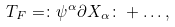Convert formula to latex. <formula><loc_0><loc_0><loc_500><loc_500>T _ { F } = \colon \psi ^ { \alpha } \partial X _ { \alpha } \colon + \dots ,</formula> 